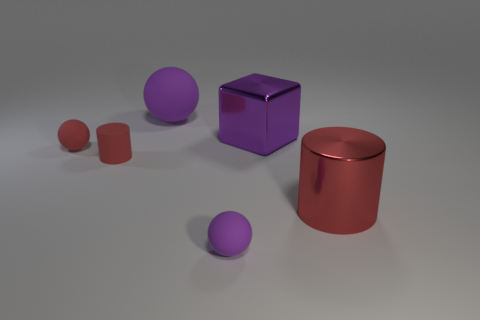There is a purple block; are there any tiny cylinders right of it?
Keep it short and to the point. No. What material is the big thing that is the same color as the big metal cube?
Provide a succinct answer. Rubber. There is a block; does it have the same size as the purple rubber ball right of the big purple sphere?
Keep it short and to the point. No. Are there any other big blocks that have the same color as the large metallic cube?
Provide a short and direct response. No. Is there a tiny red matte object of the same shape as the big purple matte object?
Provide a succinct answer. Yes. There is a tiny object that is both right of the tiny red matte ball and left of the big matte object; what is its shape?
Your answer should be compact. Cylinder. What number of purple balls are the same material as the big red cylinder?
Provide a succinct answer. 0. Are there fewer purple balls that are on the left side of the tiny cylinder than metallic cylinders?
Keep it short and to the point. Yes. There is a rubber sphere that is to the left of the large purple rubber ball; are there any cylinders in front of it?
Offer a terse response. Yes. Is there any other thing that has the same shape as the tiny purple object?
Offer a very short reply. Yes. 